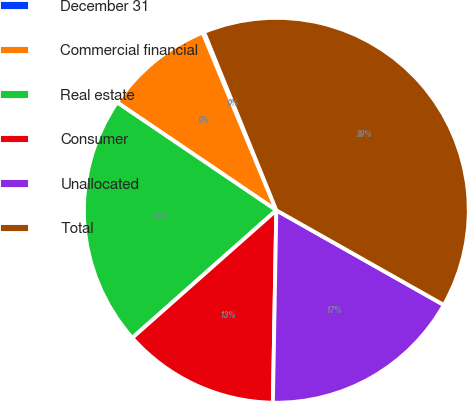Convert chart to OTSL. <chart><loc_0><loc_0><loc_500><loc_500><pie_chart><fcel>December 31<fcel>Commercial financial<fcel>Real estate<fcel>Consumer<fcel>Unallocated<fcel>Total<nl><fcel>0.13%<fcel>9.26%<fcel>21.02%<fcel>13.18%<fcel>17.1%<fcel>39.33%<nl></chart> 